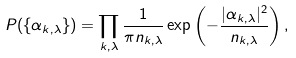Convert formula to latex. <formula><loc_0><loc_0><loc_500><loc_500>P ( \{ \alpha _ { k , \lambda } \} ) = \prod _ { k , \lambda } \frac { 1 } { \pi n _ { k , \lambda } } \exp \left ( - \frac { | \alpha _ { k , \lambda } | ^ { 2 } } { n _ { k , \lambda } } \right ) ,</formula> 